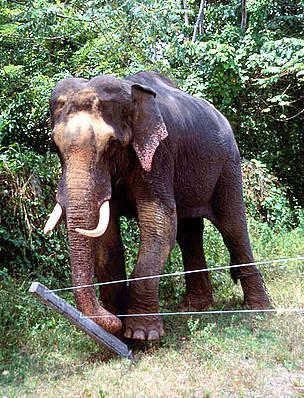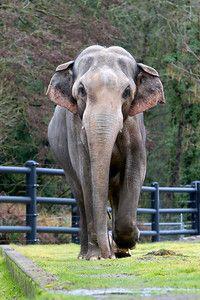The first image is the image on the left, the second image is the image on the right. For the images displayed, is the sentence "One image shows one gray baby elephant walking with no more than three adults." factually correct? Answer yes or no. No. The first image is the image on the left, the second image is the image on the right. Evaluate the accuracy of this statement regarding the images: "All elephants are headed in the same direction.". Is it true? Answer yes or no. Yes. 